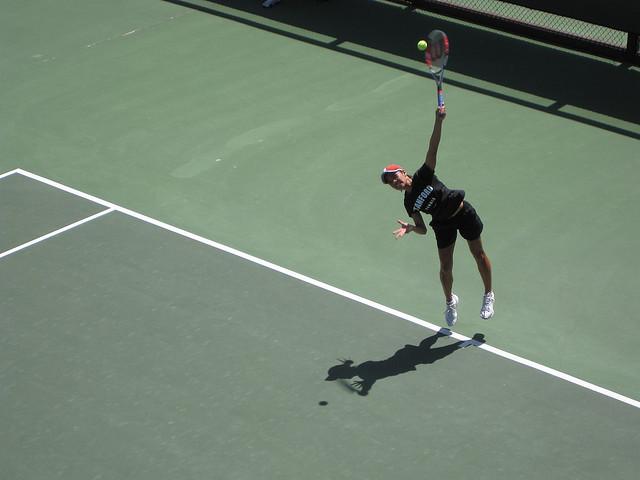What position is the woman in?
Quick response, please. Serving position. What sport is being played in this scene?
Write a very short answer. Tennis. Is this picture taken during the day?
Be succinct. Yes. 